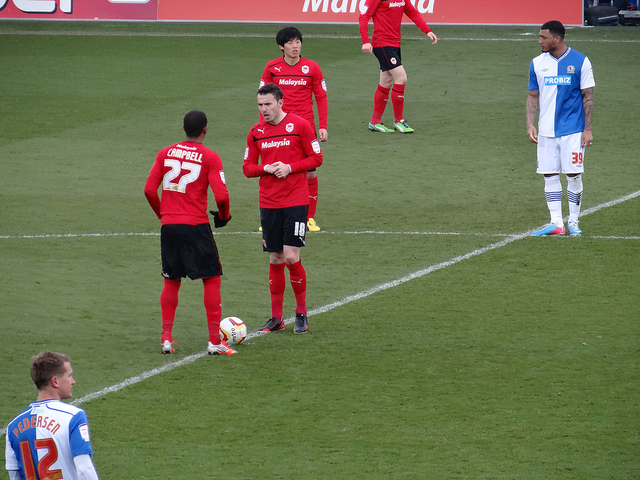<image>What team is shown? I don't know what team is shown. It could be Malaysia or another team. What team is shown? It is ambiguous what team is shown. There are two different teams on the screen: Malaysia and Spain. 